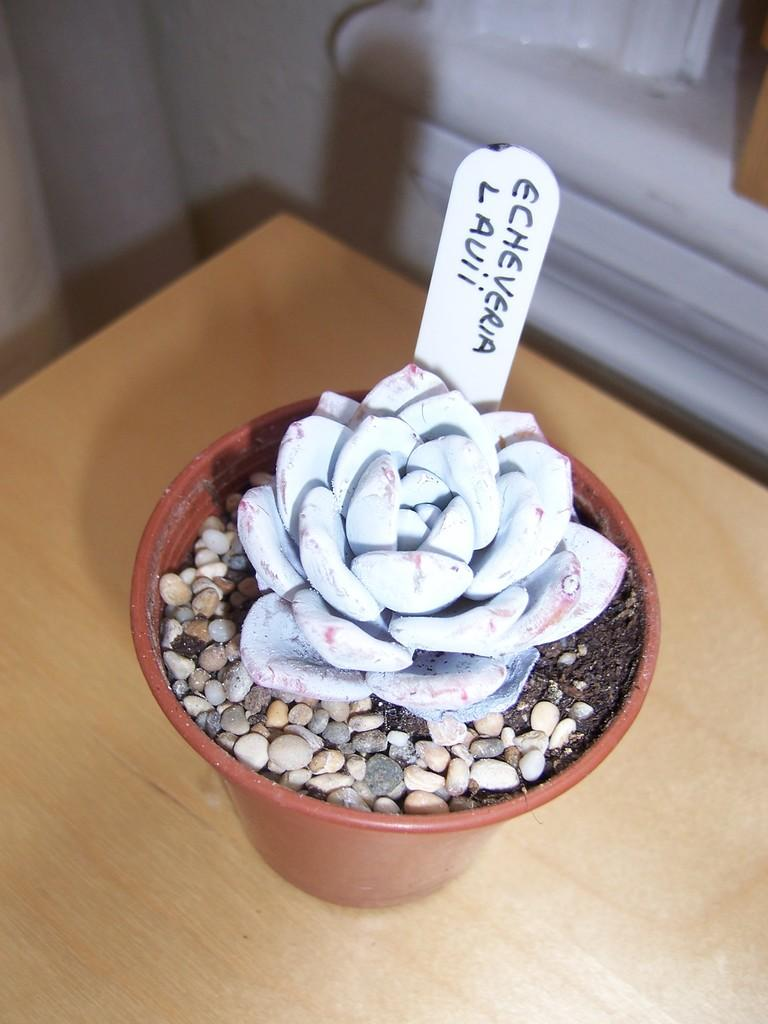What object is present in the image that might hold plants? There is a flower pot in the image. What materials are inside the flower pot? The flower pot contains small stones and mud. On what surface is the flower pot placed? The flower pot is on a brown table. What color is the background of the image? The background of the image is white. Can you see any islands or boats in the image? No, there are no islands or boats present in the image. Who is the friend that can be seen in the image? There is no friend visible in the image; it only features a flower pot on a table with a white background. 